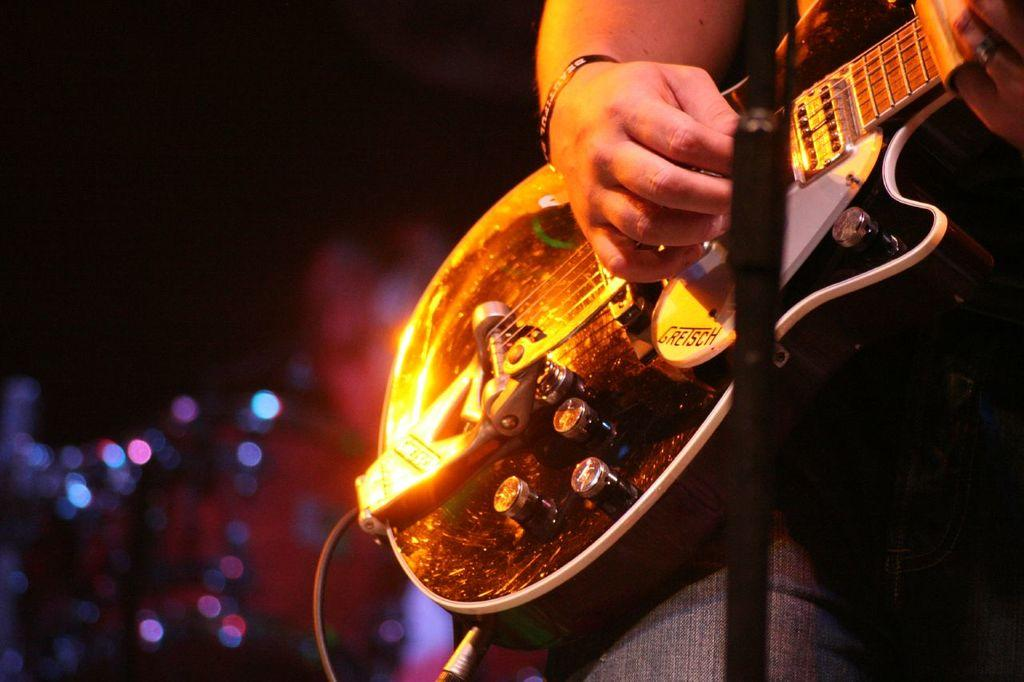What is the main subject of the image? There is a person in the image. What is the person doing in the image? The person is playing the guitar. How is the person holding the guitar? The person is holding the guitar. What is the person wearing in the image? The person is wearing a band. What can be observed about the background of the image? The background of the image is dark. Can you tell me how many airplanes are visible in the image? There are no airplanes visible in the image; the focus is on the person playing the guitar. 